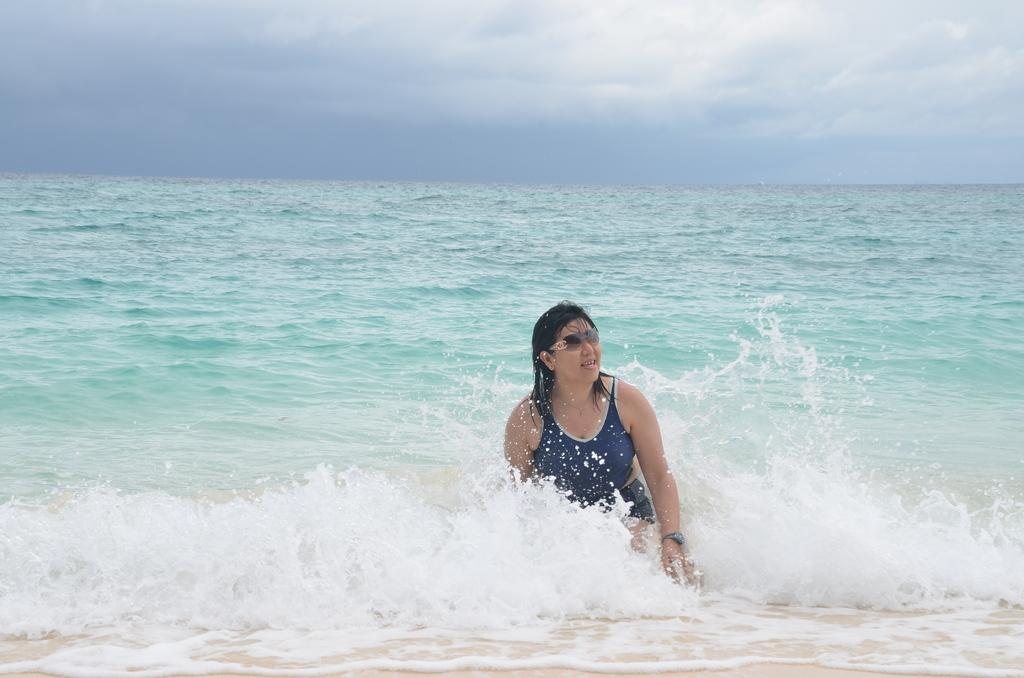Who is present in the image? There is a woman in the image. What is the woman doing in the image? The woman is in the water. What is the woman wearing in the image? The woman is wearing a dress and goggles. What can be seen in the background of the image? The sky is visible in the background of the image. What is the condition of the sky in the image? The sky appears to be cloudy. What type of yak can be seen in the image? There is no yak present in the image. What memory does the woman have of her childhood in the image? The image does not provide any information about the woman's memories or childhood. 